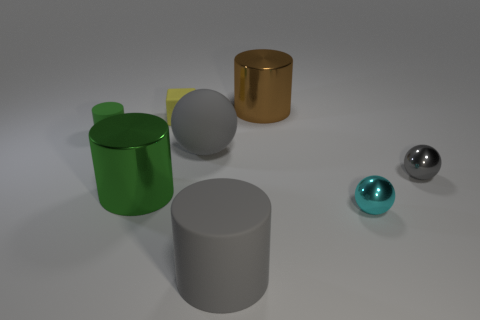How many balls are either big green objects or small brown objects?
Your response must be concise. 0. What number of gray spheres are left of the big metallic object right of the rubber cylinder on the right side of the small yellow block?
Your response must be concise. 1. There is a matte ball that is the same color as the large matte cylinder; what is its size?
Your response must be concise. Large. Are there any large gray things made of the same material as the small gray ball?
Offer a very short reply. No. Is the material of the small yellow object the same as the big gray cylinder?
Give a very brief answer. Yes. There is a metallic object behind the yellow block; how many gray objects are in front of it?
Offer a very short reply. 3. What number of blue objects are big matte cylinders or shiny spheres?
Your answer should be compact. 0. What shape is the object that is behind the yellow block that is behind the large metallic thing on the left side of the large ball?
Your answer should be very brief. Cylinder. There is a cylinder that is the same size as the cyan ball; what color is it?
Keep it short and to the point. Green. How many other metallic objects have the same shape as the green metallic object?
Provide a succinct answer. 1. 